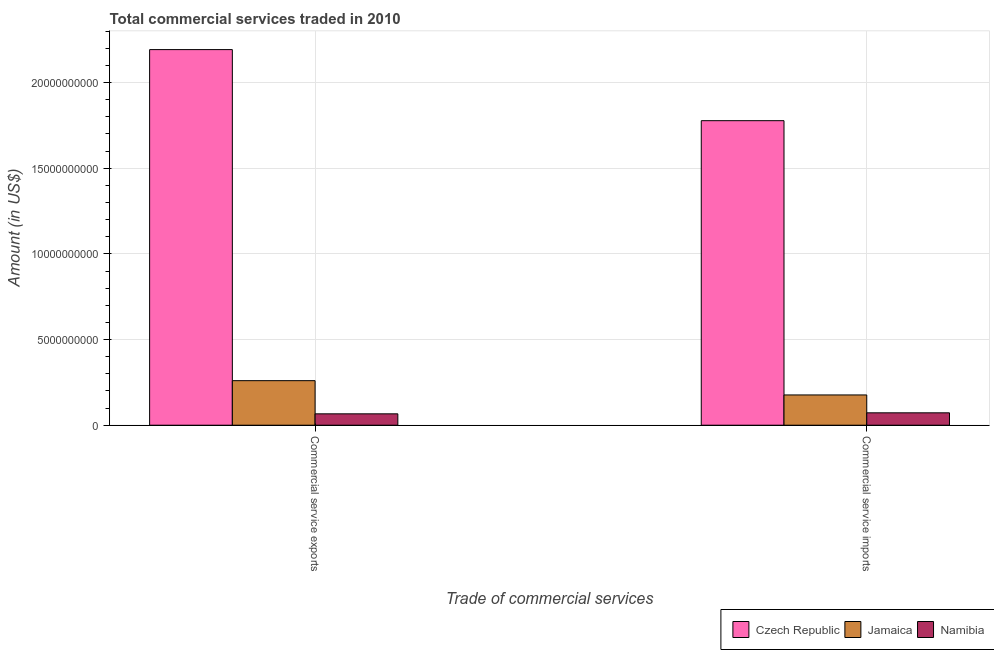Are the number of bars on each tick of the X-axis equal?
Give a very brief answer. Yes. How many bars are there on the 1st tick from the right?
Offer a very short reply. 3. What is the label of the 1st group of bars from the left?
Your response must be concise. Commercial service exports. What is the amount of commercial service imports in Namibia?
Give a very brief answer. 7.23e+08. Across all countries, what is the maximum amount of commercial service exports?
Provide a short and direct response. 2.19e+1. Across all countries, what is the minimum amount of commercial service imports?
Your answer should be very brief. 7.23e+08. In which country was the amount of commercial service imports maximum?
Offer a terse response. Czech Republic. In which country was the amount of commercial service exports minimum?
Your response must be concise. Namibia. What is the total amount of commercial service exports in the graph?
Give a very brief answer. 2.52e+1. What is the difference between the amount of commercial service exports in Namibia and that in Jamaica?
Keep it short and to the point. -1.94e+09. What is the difference between the amount of commercial service exports in Czech Republic and the amount of commercial service imports in Jamaica?
Give a very brief answer. 2.02e+1. What is the average amount of commercial service imports per country?
Offer a terse response. 6.75e+09. What is the difference between the amount of commercial service exports and amount of commercial service imports in Namibia?
Your response must be concise. -5.84e+07. What is the ratio of the amount of commercial service imports in Namibia to that in Czech Republic?
Provide a short and direct response. 0.04. Is the amount of commercial service exports in Jamaica less than that in Czech Republic?
Your answer should be very brief. Yes. In how many countries, is the amount of commercial service exports greater than the average amount of commercial service exports taken over all countries?
Ensure brevity in your answer.  1. What does the 3rd bar from the left in Commercial service exports represents?
Make the answer very short. Namibia. What does the 1st bar from the right in Commercial service imports represents?
Provide a short and direct response. Namibia. How many bars are there?
Make the answer very short. 6. How many countries are there in the graph?
Your response must be concise. 3. What is the difference between two consecutive major ticks on the Y-axis?
Provide a succinct answer. 5.00e+09. Does the graph contain grids?
Offer a terse response. Yes. Where does the legend appear in the graph?
Your answer should be very brief. Bottom right. What is the title of the graph?
Your response must be concise. Total commercial services traded in 2010. Does "Togo" appear as one of the legend labels in the graph?
Ensure brevity in your answer.  No. What is the label or title of the X-axis?
Provide a short and direct response. Trade of commercial services. What is the Amount (in US$) in Czech Republic in Commercial service exports?
Your answer should be compact. 2.19e+1. What is the Amount (in US$) of Jamaica in Commercial service exports?
Your answer should be very brief. 2.60e+09. What is the Amount (in US$) in Namibia in Commercial service exports?
Your answer should be very brief. 6.64e+08. What is the Amount (in US$) of Czech Republic in Commercial service imports?
Give a very brief answer. 1.78e+1. What is the Amount (in US$) in Jamaica in Commercial service imports?
Offer a terse response. 1.77e+09. What is the Amount (in US$) of Namibia in Commercial service imports?
Make the answer very short. 7.23e+08. Across all Trade of commercial services, what is the maximum Amount (in US$) in Czech Republic?
Make the answer very short. 2.19e+1. Across all Trade of commercial services, what is the maximum Amount (in US$) in Jamaica?
Give a very brief answer. 2.60e+09. Across all Trade of commercial services, what is the maximum Amount (in US$) of Namibia?
Your answer should be compact. 7.23e+08. Across all Trade of commercial services, what is the minimum Amount (in US$) in Czech Republic?
Your answer should be compact. 1.78e+1. Across all Trade of commercial services, what is the minimum Amount (in US$) in Jamaica?
Your answer should be compact. 1.77e+09. Across all Trade of commercial services, what is the minimum Amount (in US$) of Namibia?
Ensure brevity in your answer.  6.64e+08. What is the total Amount (in US$) of Czech Republic in the graph?
Ensure brevity in your answer.  3.97e+1. What is the total Amount (in US$) in Jamaica in the graph?
Your answer should be very brief. 4.37e+09. What is the total Amount (in US$) in Namibia in the graph?
Keep it short and to the point. 1.39e+09. What is the difference between the Amount (in US$) of Czech Republic in Commercial service exports and that in Commercial service imports?
Offer a terse response. 4.15e+09. What is the difference between the Amount (in US$) in Jamaica in Commercial service exports and that in Commercial service imports?
Your answer should be compact. 8.34e+08. What is the difference between the Amount (in US$) of Namibia in Commercial service exports and that in Commercial service imports?
Provide a succinct answer. -5.84e+07. What is the difference between the Amount (in US$) of Czech Republic in Commercial service exports and the Amount (in US$) of Jamaica in Commercial service imports?
Your answer should be very brief. 2.02e+1. What is the difference between the Amount (in US$) of Czech Republic in Commercial service exports and the Amount (in US$) of Namibia in Commercial service imports?
Offer a terse response. 2.12e+1. What is the difference between the Amount (in US$) of Jamaica in Commercial service exports and the Amount (in US$) of Namibia in Commercial service imports?
Offer a terse response. 1.88e+09. What is the average Amount (in US$) in Czech Republic per Trade of commercial services?
Provide a short and direct response. 1.99e+1. What is the average Amount (in US$) in Jamaica per Trade of commercial services?
Keep it short and to the point. 2.18e+09. What is the average Amount (in US$) in Namibia per Trade of commercial services?
Keep it short and to the point. 6.93e+08. What is the difference between the Amount (in US$) in Czech Republic and Amount (in US$) in Jamaica in Commercial service exports?
Your response must be concise. 1.93e+1. What is the difference between the Amount (in US$) in Czech Republic and Amount (in US$) in Namibia in Commercial service exports?
Offer a terse response. 2.13e+1. What is the difference between the Amount (in US$) of Jamaica and Amount (in US$) of Namibia in Commercial service exports?
Ensure brevity in your answer.  1.94e+09. What is the difference between the Amount (in US$) in Czech Republic and Amount (in US$) in Jamaica in Commercial service imports?
Ensure brevity in your answer.  1.60e+1. What is the difference between the Amount (in US$) of Czech Republic and Amount (in US$) of Namibia in Commercial service imports?
Your response must be concise. 1.71e+1. What is the difference between the Amount (in US$) in Jamaica and Amount (in US$) in Namibia in Commercial service imports?
Make the answer very short. 1.04e+09. What is the ratio of the Amount (in US$) in Czech Republic in Commercial service exports to that in Commercial service imports?
Give a very brief answer. 1.23. What is the ratio of the Amount (in US$) in Jamaica in Commercial service exports to that in Commercial service imports?
Provide a short and direct response. 1.47. What is the ratio of the Amount (in US$) of Namibia in Commercial service exports to that in Commercial service imports?
Keep it short and to the point. 0.92. What is the difference between the highest and the second highest Amount (in US$) of Czech Republic?
Give a very brief answer. 4.15e+09. What is the difference between the highest and the second highest Amount (in US$) of Jamaica?
Make the answer very short. 8.34e+08. What is the difference between the highest and the second highest Amount (in US$) in Namibia?
Make the answer very short. 5.84e+07. What is the difference between the highest and the lowest Amount (in US$) in Czech Republic?
Make the answer very short. 4.15e+09. What is the difference between the highest and the lowest Amount (in US$) of Jamaica?
Your answer should be compact. 8.34e+08. What is the difference between the highest and the lowest Amount (in US$) in Namibia?
Your answer should be compact. 5.84e+07. 